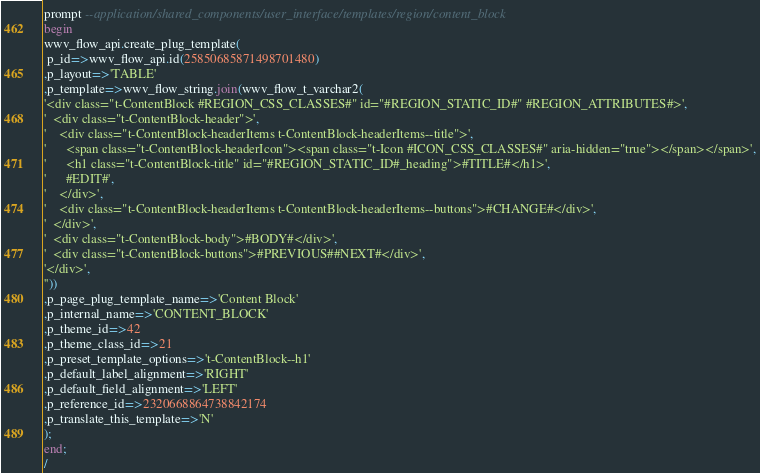Convert code to text. <code><loc_0><loc_0><loc_500><loc_500><_SQL_>prompt --application/shared_components/user_interface/templates/region/content_block
begin
wwv_flow_api.create_plug_template(
 p_id=>wwv_flow_api.id(25850685871498701480)
,p_layout=>'TABLE'
,p_template=>wwv_flow_string.join(wwv_flow_t_varchar2(
'<div class="t-ContentBlock #REGION_CSS_CLASSES#" id="#REGION_STATIC_ID#" #REGION_ATTRIBUTES#>',
'  <div class="t-ContentBlock-header">',
'    <div class="t-ContentBlock-headerItems t-ContentBlock-headerItems--title">',
'      <span class="t-ContentBlock-headerIcon"><span class="t-Icon #ICON_CSS_CLASSES#" aria-hidden="true"></span></span>',
'      <h1 class="t-ContentBlock-title" id="#REGION_STATIC_ID#_heading">#TITLE#</h1>',
'      #EDIT#',
'    </div>',
'    <div class="t-ContentBlock-headerItems t-ContentBlock-headerItems--buttons">#CHANGE#</div>',
'  </div>',
'  <div class="t-ContentBlock-body">#BODY#</div>',
'  <div class="t-ContentBlock-buttons">#PREVIOUS##NEXT#</div>',
'</div>',
''))
,p_page_plug_template_name=>'Content Block'
,p_internal_name=>'CONTENT_BLOCK'
,p_theme_id=>42
,p_theme_class_id=>21
,p_preset_template_options=>'t-ContentBlock--h1'
,p_default_label_alignment=>'RIGHT'
,p_default_field_alignment=>'LEFT'
,p_reference_id=>2320668864738842174
,p_translate_this_template=>'N'
);
end;
/
</code> 